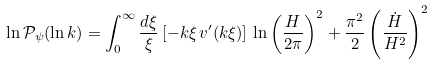Convert formula to latex. <formula><loc_0><loc_0><loc_500><loc_500>\ln \mathcal { P _ { \psi } } ( \ln k ) = \int _ { 0 } ^ { \infty } \frac { d \xi } { \xi } \left [ - k \xi \, v ^ { \prime } ( k \xi ) \right ] \, \ln \left ( \frac { H } { 2 \pi } \right ) ^ { 2 } + \frac { \pi ^ { 2 } } { 2 } \left ( \frac { \dot { H } } { H ^ { 2 } } \right ) ^ { 2 }</formula> 